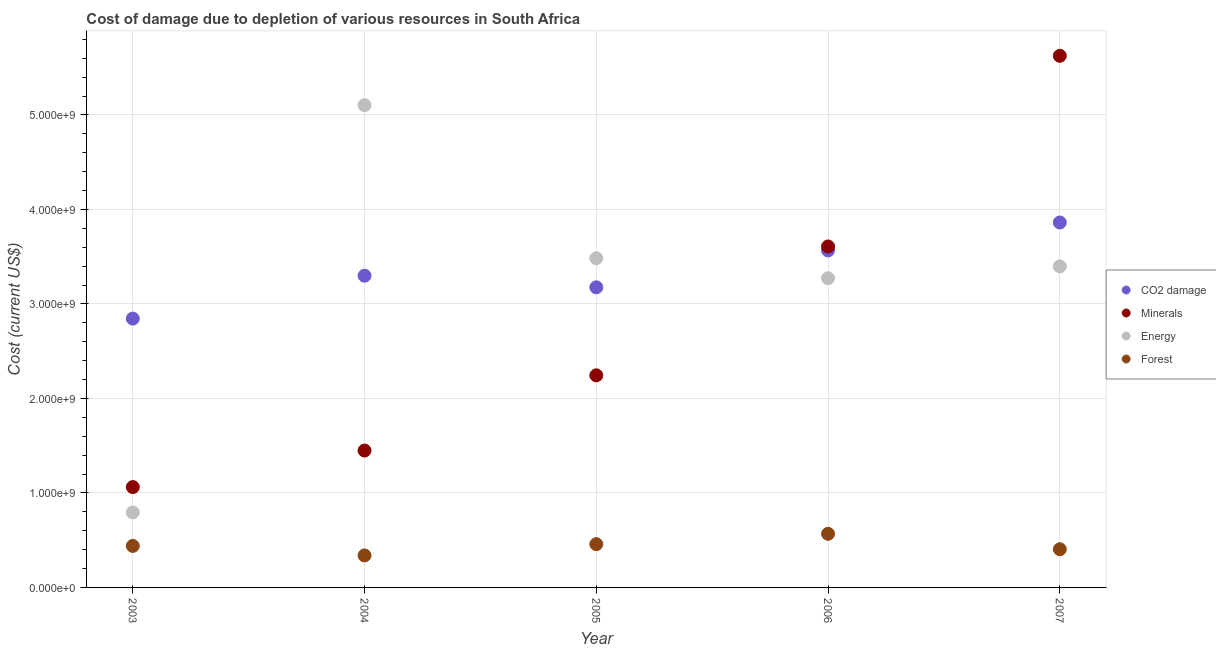Is the number of dotlines equal to the number of legend labels?
Ensure brevity in your answer.  Yes. What is the cost of damage due to depletion of minerals in 2006?
Offer a very short reply. 3.61e+09. Across all years, what is the maximum cost of damage due to depletion of energy?
Your answer should be compact. 5.10e+09. Across all years, what is the minimum cost of damage due to depletion of energy?
Offer a very short reply. 7.94e+08. In which year was the cost of damage due to depletion of forests maximum?
Your response must be concise. 2006. In which year was the cost of damage due to depletion of minerals minimum?
Offer a very short reply. 2003. What is the total cost of damage due to depletion of energy in the graph?
Offer a terse response. 1.61e+1. What is the difference between the cost of damage due to depletion of forests in 2006 and that in 2007?
Provide a succinct answer. 1.63e+08. What is the difference between the cost of damage due to depletion of minerals in 2006 and the cost of damage due to depletion of forests in 2004?
Your answer should be very brief. 3.27e+09. What is the average cost of damage due to depletion of minerals per year?
Provide a succinct answer. 2.80e+09. In the year 2004, what is the difference between the cost of damage due to depletion of forests and cost of damage due to depletion of coal?
Provide a succinct answer. -2.96e+09. What is the ratio of the cost of damage due to depletion of forests in 2005 to that in 2006?
Offer a terse response. 0.81. What is the difference between the highest and the second highest cost of damage due to depletion of forests?
Offer a terse response. 1.09e+08. What is the difference between the highest and the lowest cost of damage due to depletion of forests?
Make the answer very short. 2.29e+08. Is it the case that in every year, the sum of the cost of damage due to depletion of energy and cost of damage due to depletion of minerals is greater than the sum of cost of damage due to depletion of coal and cost of damage due to depletion of forests?
Provide a succinct answer. No. Does the cost of damage due to depletion of energy monotonically increase over the years?
Offer a very short reply. No. Is the cost of damage due to depletion of minerals strictly greater than the cost of damage due to depletion of coal over the years?
Offer a terse response. No. Is the cost of damage due to depletion of minerals strictly less than the cost of damage due to depletion of forests over the years?
Offer a terse response. No. How many dotlines are there?
Your response must be concise. 4. Are the values on the major ticks of Y-axis written in scientific E-notation?
Provide a short and direct response. Yes. Where does the legend appear in the graph?
Offer a very short reply. Center right. How are the legend labels stacked?
Your answer should be very brief. Vertical. What is the title of the graph?
Make the answer very short. Cost of damage due to depletion of various resources in South Africa . What is the label or title of the Y-axis?
Make the answer very short. Cost (current US$). What is the Cost (current US$) in CO2 damage in 2003?
Make the answer very short. 2.85e+09. What is the Cost (current US$) of Minerals in 2003?
Give a very brief answer. 1.06e+09. What is the Cost (current US$) of Energy in 2003?
Make the answer very short. 7.94e+08. What is the Cost (current US$) of Forest in 2003?
Give a very brief answer. 4.39e+08. What is the Cost (current US$) in CO2 damage in 2004?
Your answer should be compact. 3.30e+09. What is the Cost (current US$) in Minerals in 2004?
Offer a very short reply. 1.45e+09. What is the Cost (current US$) in Energy in 2004?
Your answer should be compact. 5.10e+09. What is the Cost (current US$) in Forest in 2004?
Keep it short and to the point. 3.39e+08. What is the Cost (current US$) of CO2 damage in 2005?
Your answer should be very brief. 3.18e+09. What is the Cost (current US$) in Minerals in 2005?
Provide a short and direct response. 2.24e+09. What is the Cost (current US$) in Energy in 2005?
Your answer should be very brief. 3.48e+09. What is the Cost (current US$) of Forest in 2005?
Make the answer very short. 4.58e+08. What is the Cost (current US$) of CO2 damage in 2006?
Provide a succinct answer. 3.57e+09. What is the Cost (current US$) of Minerals in 2006?
Make the answer very short. 3.61e+09. What is the Cost (current US$) of Energy in 2006?
Provide a succinct answer. 3.27e+09. What is the Cost (current US$) of Forest in 2006?
Ensure brevity in your answer.  5.67e+08. What is the Cost (current US$) of CO2 damage in 2007?
Offer a terse response. 3.86e+09. What is the Cost (current US$) of Minerals in 2007?
Provide a succinct answer. 5.63e+09. What is the Cost (current US$) of Energy in 2007?
Provide a short and direct response. 3.40e+09. What is the Cost (current US$) of Forest in 2007?
Make the answer very short. 4.04e+08. Across all years, what is the maximum Cost (current US$) in CO2 damage?
Your answer should be very brief. 3.86e+09. Across all years, what is the maximum Cost (current US$) in Minerals?
Make the answer very short. 5.63e+09. Across all years, what is the maximum Cost (current US$) of Energy?
Keep it short and to the point. 5.10e+09. Across all years, what is the maximum Cost (current US$) of Forest?
Offer a very short reply. 5.67e+08. Across all years, what is the minimum Cost (current US$) of CO2 damage?
Make the answer very short. 2.85e+09. Across all years, what is the minimum Cost (current US$) of Minerals?
Keep it short and to the point. 1.06e+09. Across all years, what is the minimum Cost (current US$) in Energy?
Offer a very short reply. 7.94e+08. Across all years, what is the minimum Cost (current US$) of Forest?
Offer a terse response. 3.39e+08. What is the total Cost (current US$) in CO2 damage in the graph?
Offer a terse response. 1.67e+1. What is the total Cost (current US$) of Minerals in the graph?
Your answer should be compact. 1.40e+1. What is the total Cost (current US$) of Energy in the graph?
Your answer should be compact. 1.61e+1. What is the total Cost (current US$) in Forest in the graph?
Your answer should be very brief. 2.21e+09. What is the difference between the Cost (current US$) of CO2 damage in 2003 and that in 2004?
Offer a very short reply. -4.54e+08. What is the difference between the Cost (current US$) of Minerals in 2003 and that in 2004?
Provide a short and direct response. -3.87e+08. What is the difference between the Cost (current US$) of Energy in 2003 and that in 2004?
Provide a short and direct response. -4.31e+09. What is the difference between the Cost (current US$) of Forest in 2003 and that in 2004?
Keep it short and to the point. 1.00e+08. What is the difference between the Cost (current US$) of CO2 damage in 2003 and that in 2005?
Offer a terse response. -3.31e+08. What is the difference between the Cost (current US$) in Minerals in 2003 and that in 2005?
Make the answer very short. -1.18e+09. What is the difference between the Cost (current US$) of Energy in 2003 and that in 2005?
Your answer should be very brief. -2.69e+09. What is the difference between the Cost (current US$) of Forest in 2003 and that in 2005?
Provide a succinct answer. -1.89e+07. What is the difference between the Cost (current US$) in CO2 damage in 2003 and that in 2006?
Provide a succinct answer. -7.21e+08. What is the difference between the Cost (current US$) of Minerals in 2003 and that in 2006?
Your answer should be compact. -2.55e+09. What is the difference between the Cost (current US$) in Energy in 2003 and that in 2006?
Offer a terse response. -2.48e+09. What is the difference between the Cost (current US$) in Forest in 2003 and that in 2006?
Ensure brevity in your answer.  -1.28e+08. What is the difference between the Cost (current US$) in CO2 damage in 2003 and that in 2007?
Provide a succinct answer. -1.02e+09. What is the difference between the Cost (current US$) in Minerals in 2003 and that in 2007?
Give a very brief answer. -4.56e+09. What is the difference between the Cost (current US$) of Energy in 2003 and that in 2007?
Offer a terse response. -2.60e+09. What is the difference between the Cost (current US$) of Forest in 2003 and that in 2007?
Ensure brevity in your answer.  3.50e+07. What is the difference between the Cost (current US$) of CO2 damage in 2004 and that in 2005?
Your response must be concise. 1.23e+08. What is the difference between the Cost (current US$) in Minerals in 2004 and that in 2005?
Ensure brevity in your answer.  -7.96e+08. What is the difference between the Cost (current US$) of Energy in 2004 and that in 2005?
Make the answer very short. 1.62e+09. What is the difference between the Cost (current US$) in Forest in 2004 and that in 2005?
Offer a very short reply. -1.19e+08. What is the difference between the Cost (current US$) in CO2 damage in 2004 and that in 2006?
Your response must be concise. -2.67e+08. What is the difference between the Cost (current US$) of Minerals in 2004 and that in 2006?
Your response must be concise. -2.16e+09. What is the difference between the Cost (current US$) of Energy in 2004 and that in 2006?
Keep it short and to the point. 1.83e+09. What is the difference between the Cost (current US$) of Forest in 2004 and that in 2006?
Offer a terse response. -2.29e+08. What is the difference between the Cost (current US$) in CO2 damage in 2004 and that in 2007?
Provide a succinct answer. -5.63e+08. What is the difference between the Cost (current US$) in Minerals in 2004 and that in 2007?
Ensure brevity in your answer.  -4.18e+09. What is the difference between the Cost (current US$) of Energy in 2004 and that in 2007?
Provide a short and direct response. 1.71e+09. What is the difference between the Cost (current US$) of Forest in 2004 and that in 2007?
Make the answer very short. -6.54e+07. What is the difference between the Cost (current US$) of CO2 damage in 2005 and that in 2006?
Your answer should be very brief. -3.91e+08. What is the difference between the Cost (current US$) of Minerals in 2005 and that in 2006?
Your answer should be very brief. -1.36e+09. What is the difference between the Cost (current US$) in Energy in 2005 and that in 2006?
Give a very brief answer. 2.12e+08. What is the difference between the Cost (current US$) of Forest in 2005 and that in 2006?
Offer a very short reply. -1.09e+08. What is the difference between the Cost (current US$) of CO2 damage in 2005 and that in 2007?
Make the answer very short. -6.86e+08. What is the difference between the Cost (current US$) of Minerals in 2005 and that in 2007?
Make the answer very short. -3.38e+09. What is the difference between the Cost (current US$) of Energy in 2005 and that in 2007?
Offer a very short reply. 8.63e+07. What is the difference between the Cost (current US$) in Forest in 2005 and that in 2007?
Offer a very short reply. 5.39e+07. What is the difference between the Cost (current US$) in CO2 damage in 2006 and that in 2007?
Your response must be concise. -2.96e+08. What is the difference between the Cost (current US$) of Minerals in 2006 and that in 2007?
Make the answer very short. -2.02e+09. What is the difference between the Cost (current US$) in Energy in 2006 and that in 2007?
Keep it short and to the point. -1.25e+08. What is the difference between the Cost (current US$) in Forest in 2006 and that in 2007?
Give a very brief answer. 1.63e+08. What is the difference between the Cost (current US$) of CO2 damage in 2003 and the Cost (current US$) of Minerals in 2004?
Make the answer very short. 1.40e+09. What is the difference between the Cost (current US$) in CO2 damage in 2003 and the Cost (current US$) in Energy in 2004?
Your answer should be compact. -2.26e+09. What is the difference between the Cost (current US$) of CO2 damage in 2003 and the Cost (current US$) of Forest in 2004?
Your answer should be compact. 2.51e+09. What is the difference between the Cost (current US$) in Minerals in 2003 and the Cost (current US$) in Energy in 2004?
Provide a succinct answer. -4.04e+09. What is the difference between the Cost (current US$) in Minerals in 2003 and the Cost (current US$) in Forest in 2004?
Keep it short and to the point. 7.23e+08. What is the difference between the Cost (current US$) in Energy in 2003 and the Cost (current US$) in Forest in 2004?
Offer a very short reply. 4.55e+08. What is the difference between the Cost (current US$) in CO2 damage in 2003 and the Cost (current US$) in Minerals in 2005?
Your answer should be compact. 6.01e+08. What is the difference between the Cost (current US$) in CO2 damage in 2003 and the Cost (current US$) in Energy in 2005?
Provide a succinct answer. -6.39e+08. What is the difference between the Cost (current US$) in CO2 damage in 2003 and the Cost (current US$) in Forest in 2005?
Keep it short and to the point. 2.39e+09. What is the difference between the Cost (current US$) in Minerals in 2003 and the Cost (current US$) in Energy in 2005?
Provide a short and direct response. -2.42e+09. What is the difference between the Cost (current US$) in Minerals in 2003 and the Cost (current US$) in Forest in 2005?
Make the answer very short. 6.04e+08. What is the difference between the Cost (current US$) of Energy in 2003 and the Cost (current US$) of Forest in 2005?
Ensure brevity in your answer.  3.36e+08. What is the difference between the Cost (current US$) in CO2 damage in 2003 and the Cost (current US$) in Minerals in 2006?
Ensure brevity in your answer.  -7.63e+08. What is the difference between the Cost (current US$) in CO2 damage in 2003 and the Cost (current US$) in Energy in 2006?
Provide a succinct answer. -4.27e+08. What is the difference between the Cost (current US$) in CO2 damage in 2003 and the Cost (current US$) in Forest in 2006?
Your answer should be compact. 2.28e+09. What is the difference between the Cost (current US$) in Minerals in 2003 and the Cost (current US$) in Energy in 2006?
Ensure brevity in your answer.  -2.21e+09. What is the difference between the Cost (current US$) in Minerals in 2003 and the Cost (current US$) in Forest in 2006?
Offer a terse response. 4.95e+08. What is the difference between the Cost (current US$) of Energy in 2003 and the Cost (current US$) of Forest in 2006?
Make the answer very short. 2.26e+08. What is the difference between the Cost (current US$) in CO2 damage in 2003 and the Cost (current US$) in Minerals in 2007?
Your answer should be compact. -2.78e+09. What is the difference between the Cost (current US$) in CO2 damage in 2003 and the Cost (current US$) in Energy in 2007?
Provide a short and direct response. -5.53e+08. What is the difference between the Cost (current US$) of CO2 damage in 2003 and the Cost (current US$) of Forest in 2007?
Your answer should be compact. 2.44e+09. What is the difference between the Cost (current US$) in Minerals in 2003 and the Cost (current US$) in Energy in 2007?
Make the answer very short. -2.34e+09. What is the difference between the Cost (current US$) of Minerals in 2003 and the Cost (current US$) of Forest in 2007?
Ensure brevity in your answer.  6.58e+08. What is the difference between the Cost (current US$) of Energy in 2003 and the Cost (current US$) of Forest in 2007?
Keep it short and to the point. 3.89e+08. What is the difference between the Cost (current US$) in CO2 damage in 2004 and the Cost (current US$) in Minerals in 2005?
Your answer should be compact. 1.05e+09. What is the difference between the Cost (current US$) of CO2 damage in 2004 and the Cost (current US$) of Energy in 2005?
Offer a terse response. -1.85e+08. What is the difference between the Cost (current US$) of CO2 damage in 2004 and the Cost (current US$) of Forest in 2005?
Provide a succinct answer. 2.84e+09. What is the difference between the Cost (current US$) of Minerals in 2004 and the Cost (current US$) of Energy in 2005?
Offer a terse response. -2.04e+09. What is the difference between the Cost (current US$) in Minerals in 2004 and the Cost (current US$) in Forest in 2005?
Your response must be concise. 9.91e+08. What is the difference between the Cost (current US$) in Energy in 2004 and the Cost (current US$) in Forest in 2005?
Offer a very short reply. 4.65e+09. What is the difference between the Cost (current US$) of CO2 damage in 2004 and the Cost (current US$) of Minerals in 2006?
Your answer should be compact. -3.09e+08. What is the difference between the Cost (current US$) of CO2 damage in 2004 and the Cost (current US$) of Energy in 2006?
Keep it short and to the point. 2.68e+07. What is the difference between the Cost (current US$) of CO2 damage in 2004 and the Cost (current US$) of Forest in 2006?
Your answer should be very brief. 2.73e+09. What is the difference between the Cost (current US$) of Minerals in 2004 and the Cost (current US$) of Energy in 2006?
Offer a very short reply. -1.82e+09. What is the difference between the Cost (current US$) in Minerals in 2004 and the Cost (current US$) in Forest in 2006?
Offer a terse response. 8.81e+08. What is the difference between the Cost (current US$) in Energy in 2004 and the Cost (current US$) in Forest in 2006?
Your answer should be compact. 4.54e+09. What is the difference between the Cost (current US$) of CO2 damage in 2004 and the Cost (current US$) of Minerals in 2007?
Provide a short and direct response. -2.33e+09. What is the difference between the Cost (current US$) in CO2 damage in 2004 and the Cost (current US$) in Energy in 2007?
Your answer should be compact. -9.85e+07. What is the difference between the Cost (current US$) in CO2 damage in 2004 and the Cost (current US$) in Forest in 2007?
Provide a short and direct response. 2.89e+09. What is the difference between the Cost (current US$) of Minerals in 2004 and the Cost (current US$) of Energy in 2007?
Keep it short and to the point. -1.95e+09. What is the difference between the Cost (current US$) of Minerals in 2004 and the Cost (current US$) of Forest in 2007?
Provide a succinct answer. 1.04e+09. What is the difference between the Cost (current US$) of Energy in 2004 and the Cost (current US$) of Forest in 2007?
Your answer should be very brief. 4.70e+09. What is the difference between the Cost (current US$) in CO2 damage in 2005 and the Cost (current US$) in Minerals in 2006?
Offer a terse response. -4.33e+08. What is the difference between the Cost (current US$) in CO2 damage in 2005 and the Cost (current US$) in Energy in 2006?
Provide a succinct answer. -9.65e+07. What is the difference between the Cost (current US$) of CO2 damage in 2005 and the Cost (current US$) of Forest in 2006?
Offer a very short reply. 2.61e+09. What is the difference between the Cost (current US$) in Minerals in 2005 and the Cost (current US$) in Energy in 2006?
Your response must be concise. -1.03e+09. What is the difference between the Cost (current US$) of Minerals in 2005 and the Cost (current US$) of Forest in 2006?
Your answer should be very brief. 1.68e+09. What is the difference between the Cost (current US$) of Energy in 2005 and the Cost (current US$) of Forest in 2006?
Make the answer very short. 2.92e+09. What is the difference between the Cost (current US$) of CO2 damage in 2005 and the Cost (current US$) of Minerals in 2007?
Provide a succinct answer. -2.45e+09. What is the difference between the Cost (current US$) in CO2 damage in 2005 and the Cost (current US$) in Energy in 2007?
Keep it short and to the point. -2.22e+08. What is the difference between the Cost (current US$) in CO2 damage in 2005 and the Cost (current US$) in Forest in 2007?
Give a very brief answer. 2.77e+09. What is the difference between the Cost (current US$) of Minerals in 2005 and the Cost (current US$) of Energy in 2007?
Give a very brief answer. -1.15e+09. What is the difference between the Cost (current US$) of Minerals in 2005 and the Cost (current US$) of Forest in 2007?
Offer a terse response. 1.84e+09. What is the difference between the Cost (current US$) of Energy in 2005 and the Cost (current US$) of Forest in 2007?
Keep it short and to the point. 3.08e+09. What is the difference between the Cost (current US$) of CO2 damage in 2006 and the Cost (current US$) of Minerals in 2007?
Give a very brief answer. -2.06e+09. What is the difference between the Cost (current US$) in CO2 damage in 2006 and the Cost (current US$) in Energy in 2007?
Give a very brief answer. 1.69e+08. What is the difference between the Cost (current US$) in CO2 damage in 2006 and the Cost (current US$) in Forest in 2007?
Keep it short and to the point. 3.16e+09. What is the difference between the Cost (current US$) in Minerals in 2006 and the Cost (current US$) in Energy in 2007?
Ensure brevity in your answer.  2.11e+08. What is the difference between the Cost (current US$) in Minerals in 2006 and the Cost (current US$) in Forest in 2007?
Give a very brief answer. 3.20e+09. What is the difference between the Cost (current US$) in Energy in 2006 and the Cost (current US$) in Forest in 2007?
Keep it short and to the point. 2.87e+09. What is the average Cost (current US$) of CO2 damage per year?
Your answer should be very brief. 3.35e+09. What is the average Cost (current US$) of Minerals per year?
Give a very brief answer. 2.80e+09. What is the average Cost (current US$) of Energy per year?
Provide a succinct answer. 3.21e+09. What is the average Cost (current US$) of Forest per year?
Your answer should be very brief. 4.42e+08. In the year 2003, what is the difference between the Cost (current US$) in CO2 damage and Cost (current US$) in Minerals?
Keep it short and to the point. 1.78e+09. In the year 2003, what is the difference between the Cost (current US$) in CO2 damage and Cost (current US$) in Energy?
Keep it short and to the point. 2.05e+09. In the year 2003, what is the difference between the Cost (current US$) of CO2 damage and Cost (current US$) of Forest?
Make the answer very short. 2.41e+09. In the year 2003, what is the difference between the Cost (current US$) in Minerals and Cost (current US$) in Energy?
Provide a short and direct response. 2.69e+08. In the year 2003, what is the difference between the Cost (current US$) in Minerals and Cost (current US$) in Forest?
Give a very brief answer. 6.23e+08. In the year 2003, what is the difference between the Cost (current US$) in Energy and Cost (current US$) in Forest?
Your answer should be very brief. 3.54e+08. In the year 2004, what is the difference between the Cost (current US$) of CO2 damage and Cost (current US$) of Minerals?
Make the answer very short. 1.85e+09. In the year 2004, what is the difference between the Cost (current US$) of CO2 damage and Cost (current US$) of Energy?
Make the answer very short. -1.80e+09. In the year 2004, what is the difference between the Cost (current US$) in CO2 damage and Cost (current US$) in Forest?
Make the answer very short. 2.96e+09. In the year 2004, what is the difference between the Cost (current US$) of Minerals and Cost (current US$) of Energy?
Your answer should be compact. -3.65e+09. In the year 2004, what is the difference between the Cost (current US$) of Minerals and Cost (current US$) of Forest?
Keep it short and to the point. 1.11e+09. In the year 2004, what is the difference between the Cost (current US$) of Energy and Cost (current US$) of Forest?
Your response must be concise. 4.76e+09. In the year 2005, what is the difference between the Cost (current US$) of CO2 damage and Cost (current US$) of Minerals?
Give a very brief answer. 9.31e+08. In the year 2005, what is the difference between the Cost (current US$) in CO2 damage and Cost (current US$) in Energy?
Your answer should be compact. -3.08e+08. In the year 2005, what is the difference between the Cost (current US$) of CO2 damage and Cost (current US$) of Forest?
Your answer should be compact. 2.72e+09. In the year 2005, what is the difference between the Cost (current US$) of Minerals and Cost (current US$) of Energy?
Make the answer very short. -1.24e+09. In the year 2005, what is the difference between the Cost (current US$) of Minerals and Cost (current US$) of Forest?
Your response must be concise. 1.79e+09. In the year 2005, what is the difference between the Cost (current US$) of Energy and Cost (current US$) of Forest?
Give a very brief answer. 3.03e+09. In the year 2006, what is the difference between the Cost (current US$) of CO2 damage and Cost (current US$) of Minerals?
Offer a very short reply. -4.21e+07. In the year 2006, what is the difference between the Cost (current US$) in CO2 damage and Cost (current US$) in Energy?
Provide a succinct answer. 2.94e+08. In the year 2006, what is the difference between the Cost (current US$) of CO2 damage and Cost (current US$) of Forest?
Make the answer very short. 3.00e+09. In the year 2006, what is the difference between the Cost (current US$) in Minerals and Cost (current US$) in Energy?
Your response must be concise. 3.36e+08. In the year 2006, what is the difference between the Cost (current US$) in Minerals and Cost (current US$) in Forest?
Keep it short and to the point. 3.04e+09. In the year 2006, what is the difference between the Cost (current US$) of Energy and Cost (current US$) of Forest?
Your response must be concise. 2.70e+09. In the year 2007, what is the difference between the Cost (current US$) of CO2 damage and Cost (current US$) of Minerals?
Offer a terse response. -1.76e+09. In the year 2007, what is the difference between the Cost (current US$) of CO2 damage and Cost (current US$) of Energy?
Your response must be concise. 4.65e+08. In the year 2007, what is the difference between the Cost (current US$) in CO2 damage and Cost (current US$) in Forest?
Keep it short and to the point. 3.46e+09. In the year 2007, what is the difference between the Cost (current US$) in Minerals and Cost (current US$) in Energy?
Offer a very short reply. 2.23e+09. In the year 2007, what is the difference between the Cost (current US$) in Minerals and Cost (current US$) in Forest?
Make the answer very short. 5.22e+09. In the year 2007, what is the difference between the Cost (current US$) in Energy and Cost (current US$) in Forest?
Make the answer very short. 2.99e+09. What is the ratio of the Cost (current US$) in CO2 damage in 2003 to that in 2004?
Ensure brevity in your answer.  0.86. What is the ratio of the Cost (current US$) in Minerals in 2003 to that in 2004?
Keep it short and to the point. 0.73. What is the ratio of the Cost (current US$) of Energy in 2003 to that in 2004?
Your answer should be very brief. 0.16. What is the ratio of the Cost (current US$) in Forest in 2003 to that in 2004?
Keep it short and to the point. 1.3. What is the ratio of the Cost (current US$) in CO2 damage in 2003 to that in 2005?
Your answer should be compact. 0.9. What is the ratio of the Cost (current US$) of Minerals in 2003 to that in 2005?
Keep it short and to the point. 0.47. What is the ratio of the Cost (current US$) of Energy in 2003 to that in 2005?
Give a very brief answer. 0.23. What is the ratio of the Cost (current US$) in Forest in 2003 to that in 2005?
Keep it short and to the point. 0.96. What is the ratio of the Cost (current US$) in CO2 damage in 2003 to that in 2006?
Make the answer very short. 0.8. What is the ratio of the Cost (current US$) in Minerals in 2003 to that in 2006?
Give a very brief answer. 0.29. What is the ratio of the Cost (current US$) in Energy in 2003 to that in 2006?
Ensure brevity in your answer.  0.24. What is the ratio of the Cost (current US$) in Forest in 2003 to that in 2006?
Keep it short and to the point. 0.77. What is the ratio of the Cost (current US$) of CO2 damage in 2003 to that in 2007?
Ensure brevity in your answer.  0.74. What is the ratio of the Cost (current US$) of Minerals in 2003 to that in 2007?
Your answer should be compact. 0.19. What is the ratio of the Cost (current US$) in Energy in 2003 to that in 2007?
Provide a short and direct response. 0.23. What is the ratio of the Cost (current US$) in Forest in 2003 to that in 2007?
Your answer should be compact. 1.09. What is the ratio of the Cost (current US$) of CO2 damage in 2004 to that in 2005?
Give a very brief answer. 1.04. What is the ratio of the Cost (current US$) of Minerals in 2004 to that in 2005?
Provide a short and direct response. 0.65. What is the ratio of the Cost (current US$) in Energy in 2004 to that in 2005?
Your answer should be compact. 1.46. What is the ratio of the Cost (current US$) in Forest in 2004 to that in 2005?
Offer a very short reply. 0.74. What is the ratio of the Cost (current US$) of CO2 damage in 2004 to that in 2006?
Your answer should be compact. 0.93. What is the ratio of the Cost (current US$) in Minerals in 2004 to that in 2006?
Your response must be concise. 0.4. What is the ratio of the Cost (current US$) of Energy in 2004 to that in 2006?
Ensure brevity in your answer.  1.56. What is the ratio of the Cost (current US$) of Forest in 2004 to that in 2006?
Your response must be concise. 0.6. What is the ratio of the Cost (current US$) of CO2 damage in 2004 to that in 2007?
Provide a succinct answer. 0.85. What is the ratio of the Cost (current US$) of Minerals in 2004 to that in 2007?
Offer a terse response. 0.26. What is the ratio of the Cost (current US$) of Energy in 2004 to that in 2007?
Offer a very short reply. 1.5. What is the ratio of the Cost (current US$) of Forest in 2004 to that in 2007?
Your answer should be compact. 0.84. What is the ratio of the Cost (current US$) in CO2 damage in 2005 to that in 2006?
Ensure brevity in your answer.  0.89. What is the ratio of the Cost (current US$) in Minerals in 2005 to that in 2006?
Keep it short and to the point. 0.62. What is the ratio of the Cost (current US$) in Energy in 2005 to that in 2006?
Keep it short and to the point. 1.06. What is the ratio of the Cost (current US$) in Forest in 2005 to that in 2006?
Your answer should be compact. 0.81. What is the ratio of the Cost (current US$) in CO2 damage in 2005 to that in 2007?
Provide a short and direct response. 0.82. What is the ratio of the Cost (current US$) of Minerals in 2005 to that in 2007?
Give a very brief answer. 0.4. What is the ratio of the Cost (current US$) in Energy in 2005 to that in 2007?
Your answer should be compact. 1.03. What is the ratio of the Cost (current US$) of Forest in 2005 to that in 2007?
Make the answer very short. 1.13. What is the ratio of the Cost (current US$) in CO2 damage in 2006 to that in 2007?
Offer a very short reply. 0.92. What is the ratio of the Cost (current US$) in Minerals in 2006 to that in 2007?
Provide a succinct answer. 0.64. What is the ratio of the Cost (current US$) of Energy in 2006 to that in 2007?
Keep it short and to the point. 0.96. What is the ratio of the Cost (current US$) of Forest in 2006 to that in 2007?
Your answer should be very brief. 1.4. What is the difference between the highest and the second highest Cost (current US$) in CO2 damage?
Keep it short and to the point. 2.96e+08. What is the difference between the highest and the second highest Cost (current US$) in Minerals?
Keep it short and to the point. 2.02e+09. What is the difference between the highest and the second highest Cost (current US$) in Energy?
Ensure brevity in your answer.  1.62e+09. What is the difference between the highest and the second highest Cost (current US$) of Forest?
Provide a short and direct response. 1.09e+08. What is the difference between the highest and the lowest Cost (current US$) in CO2 damage?
Your response must be concise. 1.02e+09. What is the difference between the highest and the lowest Cost (current US$) of Minerals?
Provide a succinct answer. 4.56e+09. What is the difference between the highest and the lowest Cost (current US$) in Energy?
Keep it short and to the point. 4.31e+09. What is the difference between the highest and the lowest Cost (current US$) in Forest?
Your answer should be compact. 2.29e+08. 